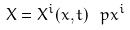<formula> <loc_0><loc_0><loc_500><loc_500>X = X ^ { i } ( x , t ) \, \ p { x ^ { i } }</formula> 